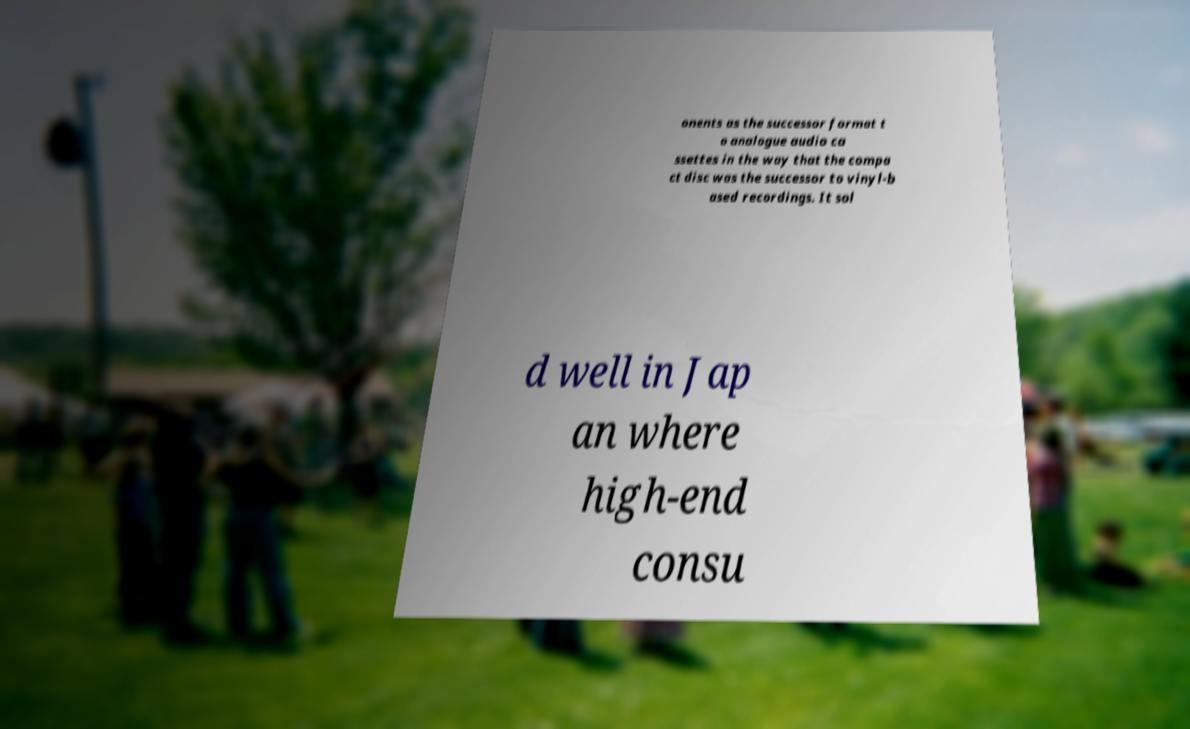I need the written content from this picture converted into text. Can you do that? onents as the successor format t o analogue audio ca ssettes in the way that the compa ct disc was the successor to vinyl-b ased recordings. It sol d well in Jap an where high-end consu 